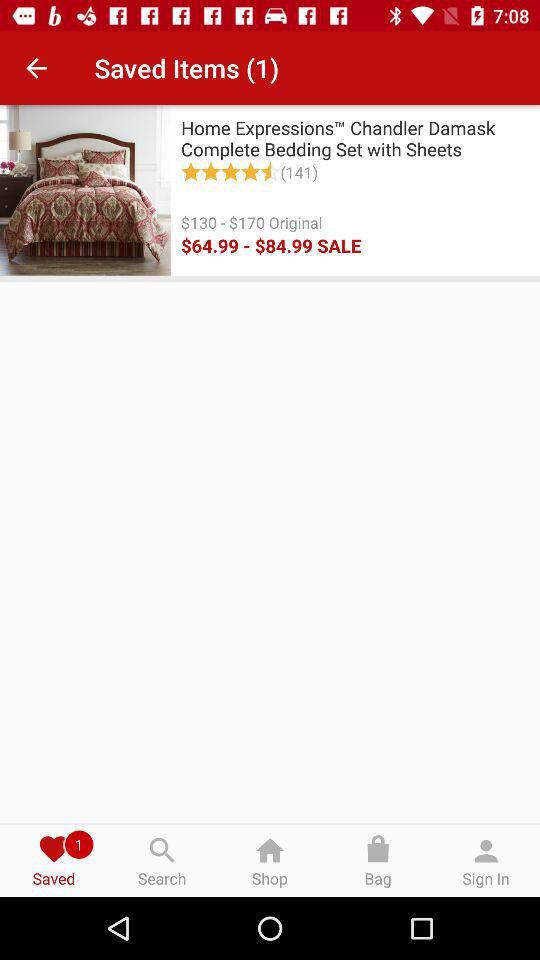What is the rating of the product? The rating of the product is 4.5 stars. 